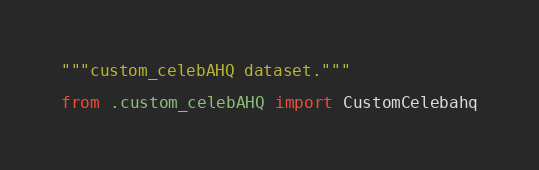Convert code to text. <code><loc_0><loc_0><loc_500><loc_500><_Python_>"""custom_celebAHQ dataset."""

from .custom_celebAHQ import CustomCelebahq
</code> 